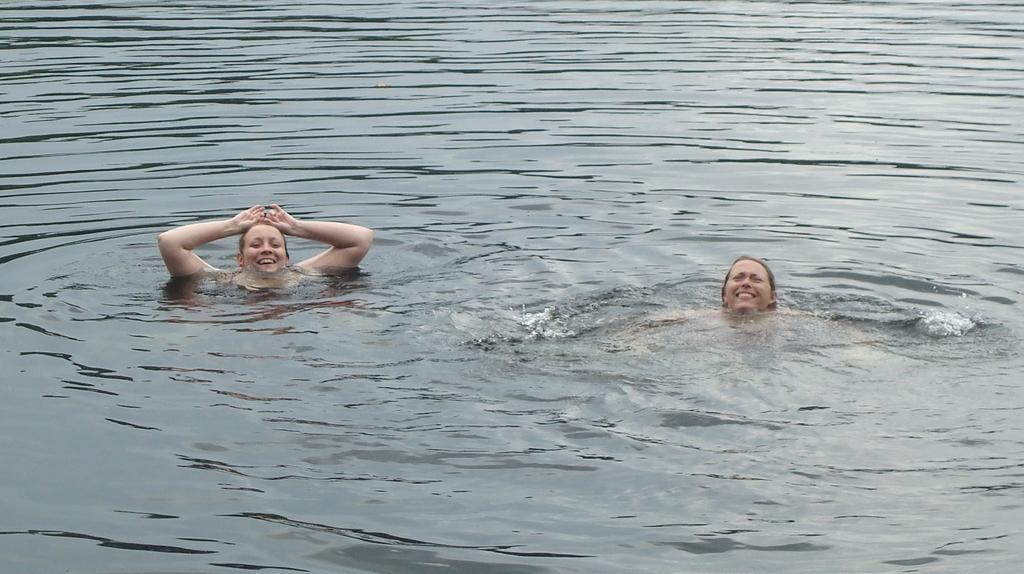Could you give a brief overview of what you see in this image? In this image I can see two women are in the water. These women are smiling. 